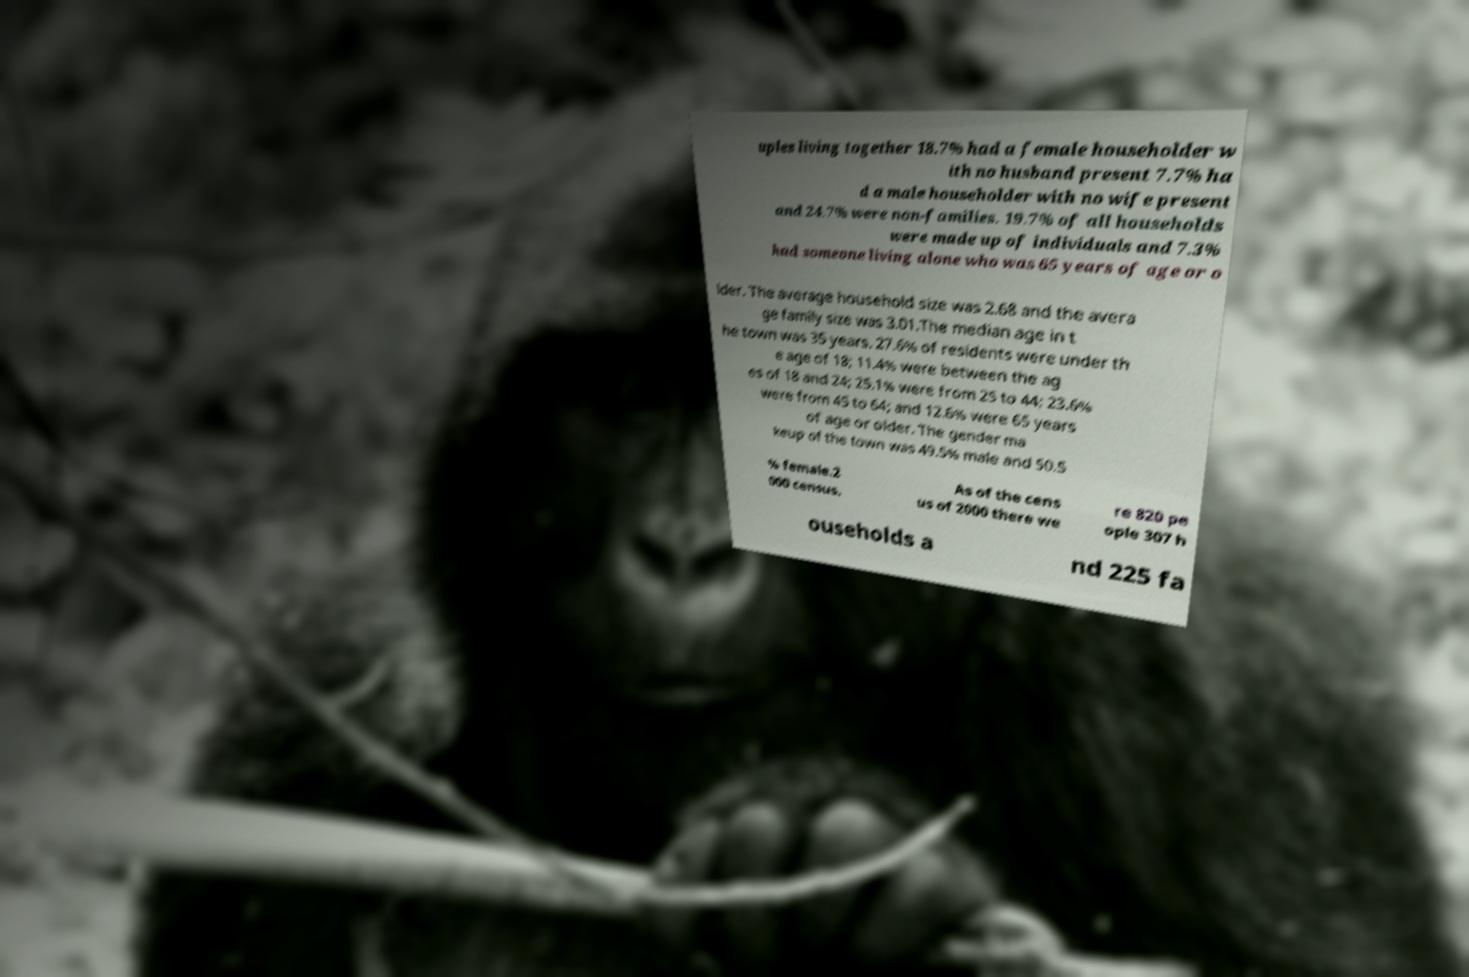Can you read and provide the text displayed in the image?This photo seems to have some interesting text. Can you extract and type it out for me? uples living together 18.7% had a female householder w ith no husband present 7.7% ha d a male householder with no wife present and 24.7% were non-families. 19.7% of all households were made up of individuals and 7.3% had someone living alone who was 65 years of age or o lder. The average household size was 2.68 and the avera ge family size was 3.01.The median age in t he town was 35 years. 27.6% of residents were under th e age of 18; 11.4% were between the ag es of 18 and 24; 25.1% were from 25 to 44; 23.6% were from 45 to 64; and 12.6% were 65 years of age or older. The gender ma keup of the town was 49.5% male and 50.5 % female.2 000 census. As of the cens us of 2000 there we re 820 pe ople 307 h ouseholds a nd 225 fa 